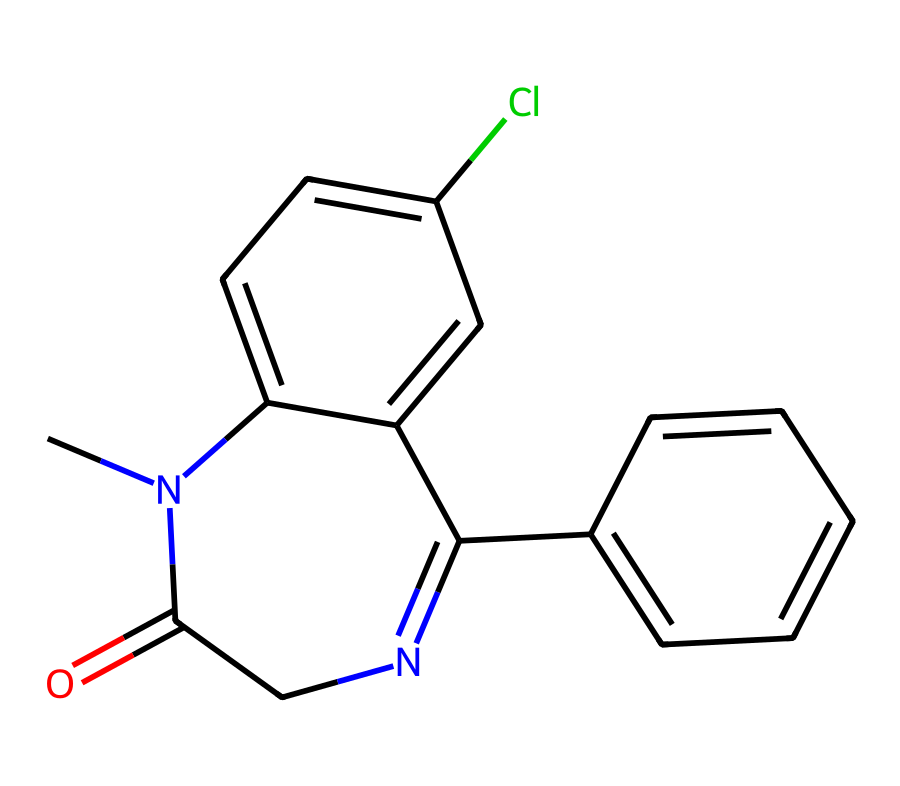What is the main functional group present in this compound? The compound features a carbonyl group (C=O) indicated by the "=O" part of the SMILES, which is characteristic of amides and contributes to its benzodiazepine structure.
Answer: carbonyl group How many nitrogen atoms are in this compound? By examining the SMILES, we identify two instances of "N" which represent nitrogen atoms. Thus, the total count is two.
Answer: two What ring system is present in this chemical structure? The SMILES indicates a fused ring structure containing two benzene rings (c1ccccc1 and c2ccccc2) and a five-membered ring involving nitrogen, typical of benzodiazepines.
Answer: fused ring system Is this compound likely to be a stimulant or a depressant? Given that benzodiazepines are generally classified as central nervous system depressants, this compound is likely to have a similar effect.
Answer: depressant What commonly associated compound often interacts with benzodiazepines in DUI cases? Benzodiazepines are commonly found in combination with alcohol, which exacerbates their sedative effects and is significant in DUI cases.
Answer: alcohol What type of molecular interaction can occur between benzodiazepines and alcohol? The interactions typically involve synergistic effects, where both substances enhance each other's sedative properties leading to increased impairment.
Answer: synergistic effects What does the presence of chlorine in the structure suggest about its properties? The chlorine atom (Cl) in the structure could indicate increased potency or altered pharmacokinetics, as halogens often modify the activity and binding affinity of drugs.
Answer: increased potency 